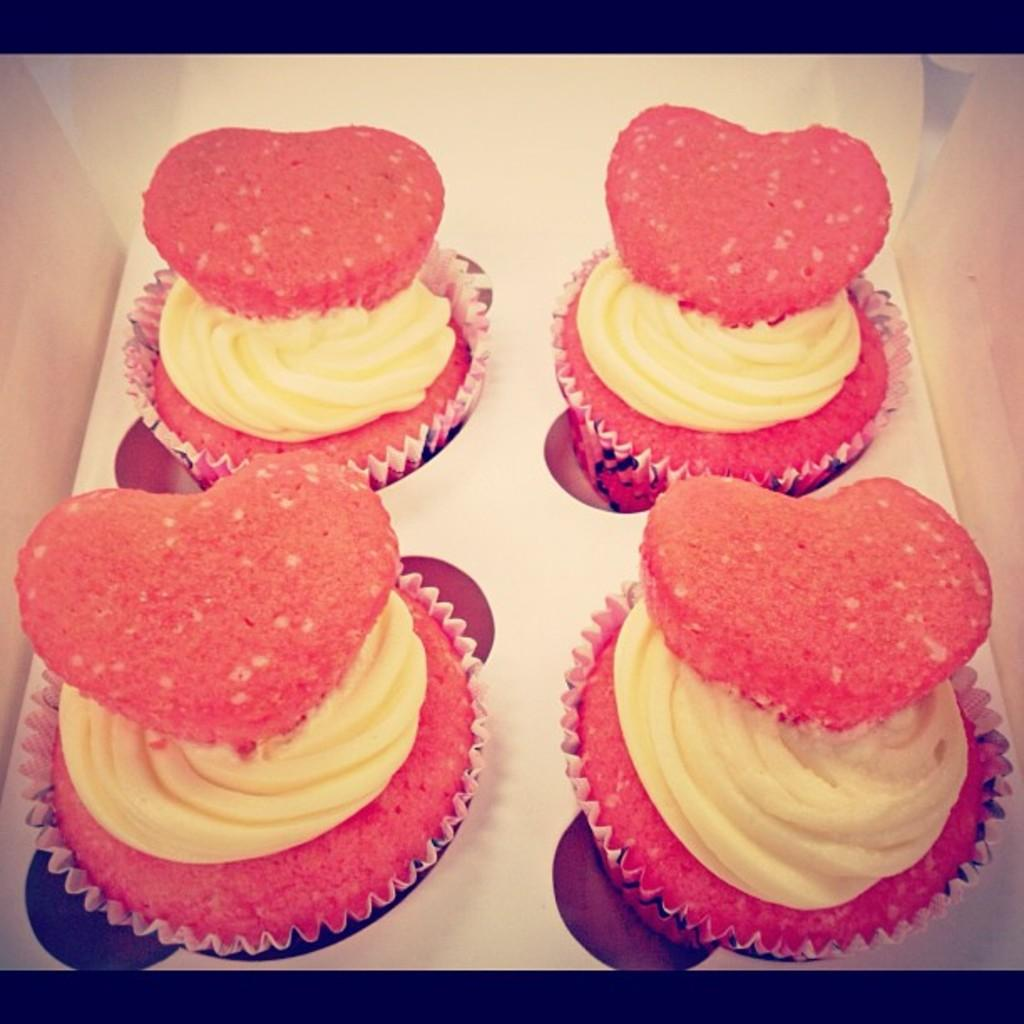What type of food can be seen in the image? There are cupcakes in the image. How are the cupcakes arranged or contained in the image? The cupcakes are in a box. Is there a woman sleeping on a bed in the image? No, there is no woman or bed present in the image; it only features cupcakes in a box. 